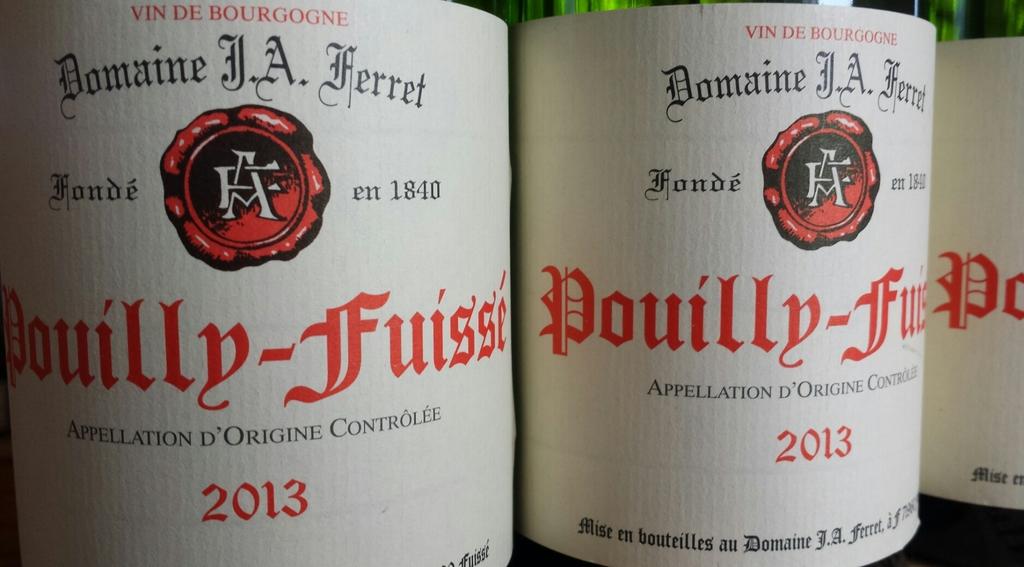What year is this drink?
Make the answer very short. 2013. What is the brand of drink?
Your answer should be compact. Pouilly-fuisse. 